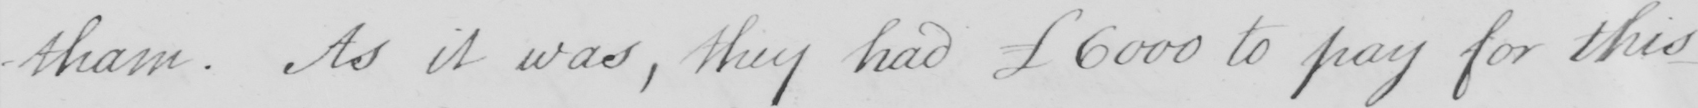What is written in this line of handwriting? -tham . As it was , they had  £6000 to pay for this 